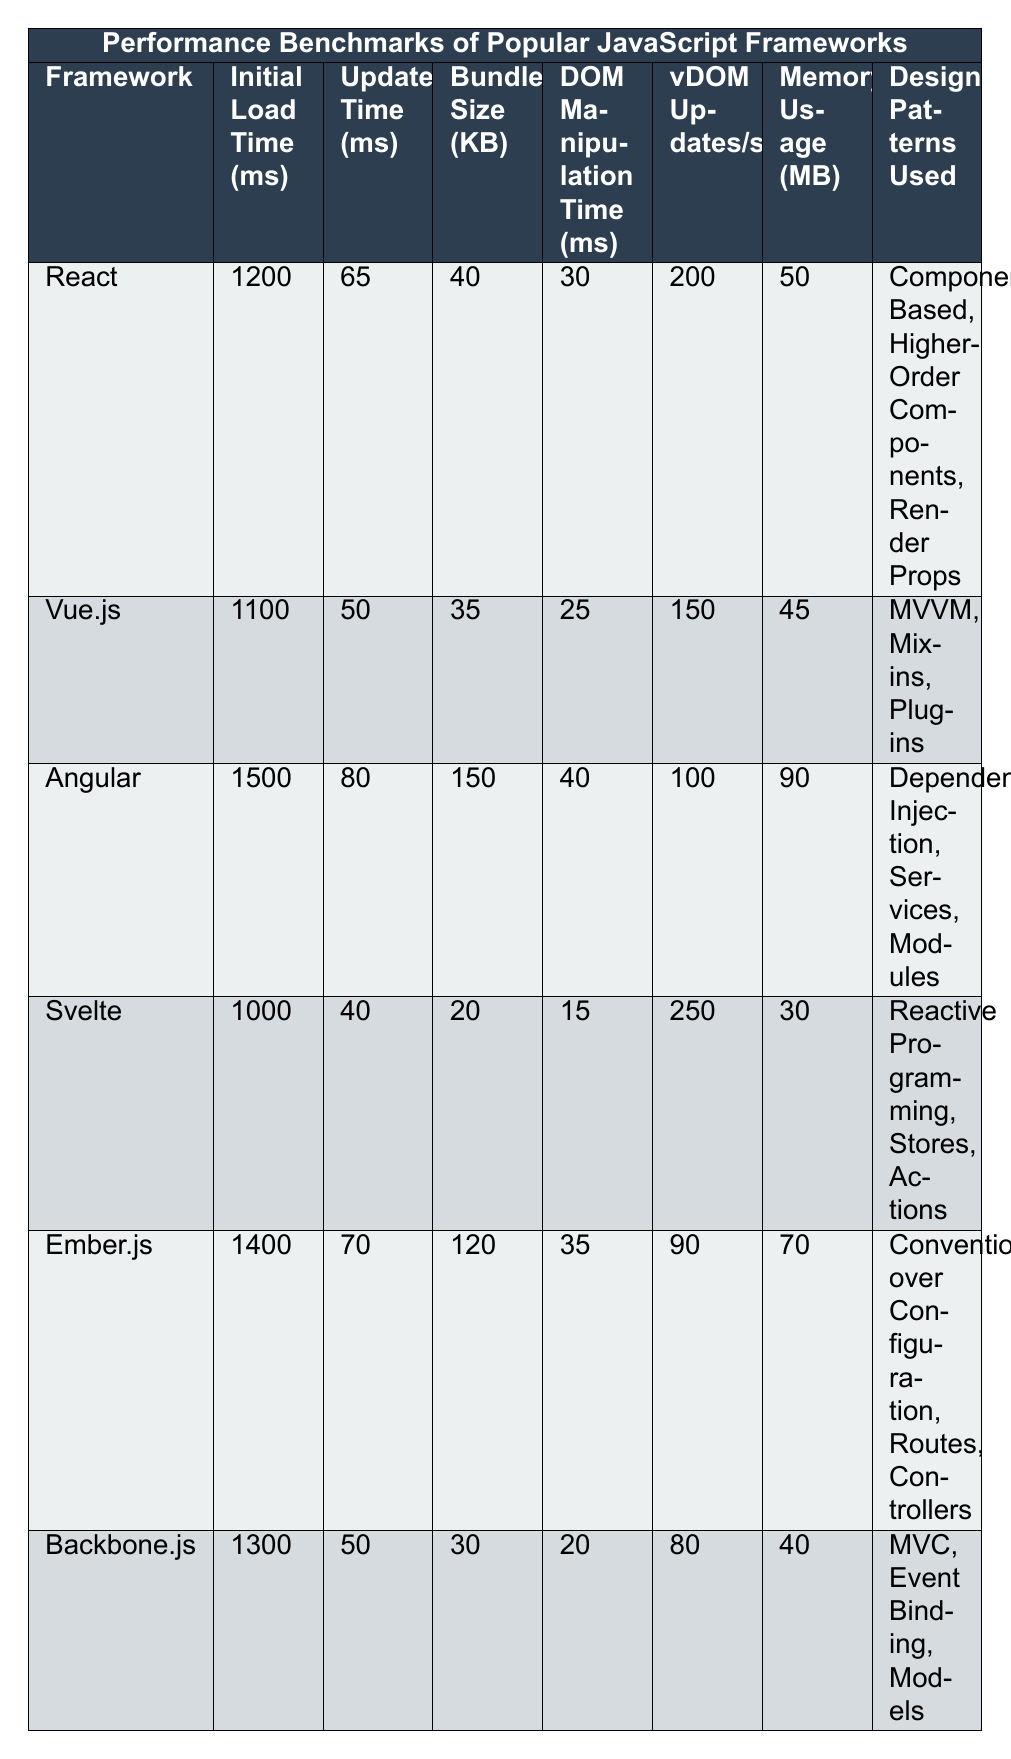What is the initial load time of Vue.js? The table lists the initial load time for Vue.js as 1100 milliseconds.
Answer: 1100 ms Which framework has the smallest bundle size? By looking at the bundle sizes in the table, Svelte has the smallest size at 20 KB.
Answer: Svelte What is the average update time of React and Vue.js? The update times for React and Vue.js are 65 ms and 50 ms respectively. Adding them gives 115 ms, and dividing by 2 results in an average of 57.5 ms.
Answer: 57.5 ms What is the difference in initial load time between Angular and Svelte? Angular's initial load time is 1500 ms, and Svelte's is 1000 ms. The difference is 1500 ms - 1000 ms = 500 ms.
Answer: 500 ms Do any frameworks use "Component-Based" design patterns? Referring to the design patterns used, React is the only framework that uses "Component-Based" as one of its patterns.
Answer: Yes Which framework has the highest vDOM updates per second? Svelte has the highest vDOM updates per second at 250.
Answer: Svelte What is the total memory usage of Angular and Ember.js combined? Angular uses 90 MB and Ember.js uses 70 MB, so the total memory usage is 90 MB + 70 MB = 160 MB.
Answer: 160 MB Does Backbone.js have a better DOM manipulation time than React? Backbone.js has a DOM manipulation time of 20 ms, while React has 30 ms. Since 20 ms is less than 30 ms, Backbone.js performs better.
Answer: Yes Which framework has the longest initial load time? According to the table, Angular has the longest initial load time at 1500 ms.
Answer: Angular How many frameworks have an update time less than 65 ms? Only Vue.js and Svelte have update times of 50 ms and 40 ms respectively. Therefore, there are 2 frameworks under 65 ms.
Answer: 2 